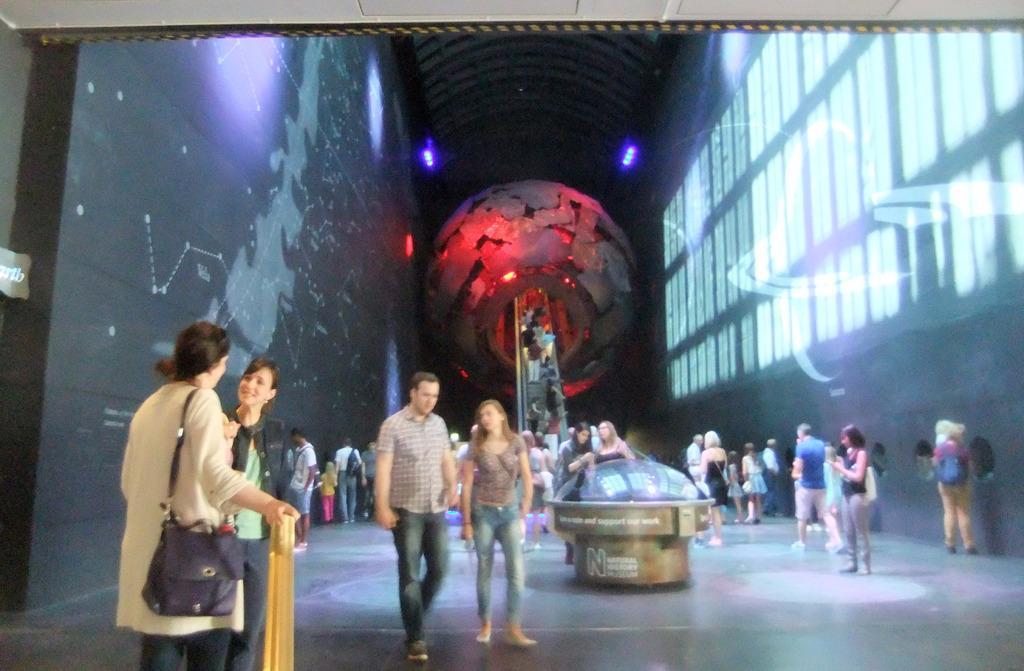Can you describe this image briefly? In this image we can see there are people walking on the floor and there is the person holding stick. And there is the globe structure with stairs and there are a few people walking on the stairs. On the right side, we can see the windows and on the left side, there is the wall with a screen. And there is the object on the floor. At the top there are lights. 